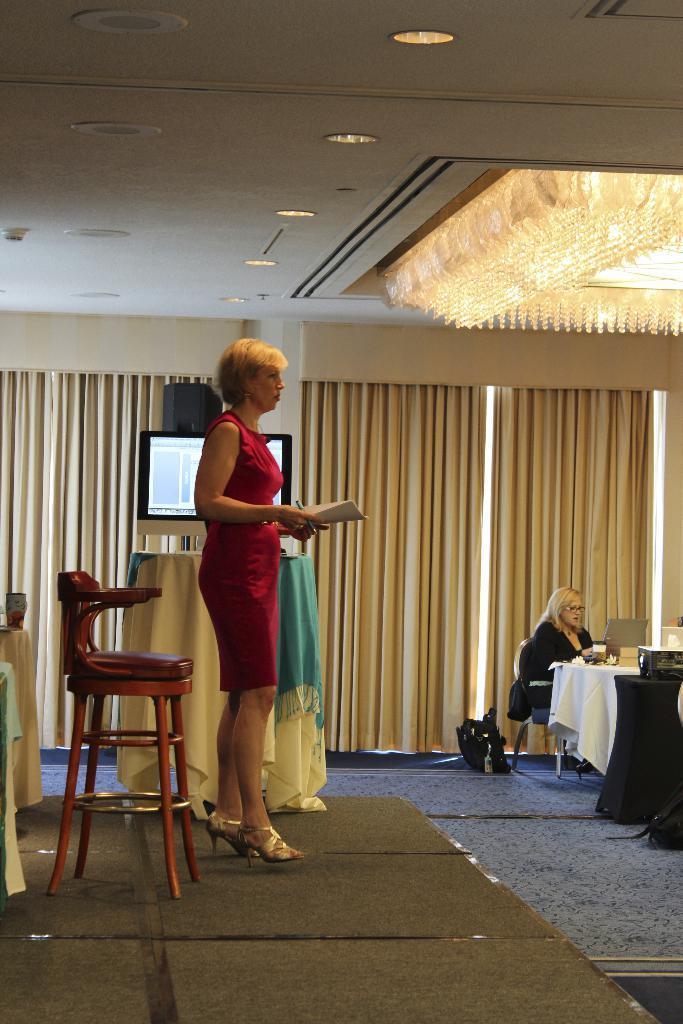In one or two sentences, can you explain what this image depicts? A women in red color dress, standing and looking at the people in front of her. A chair is near to her. In the background, a women i sitting in front of a table which is decorated with white color cloth. In the background, there is curtain , monitor, floor and lights. 